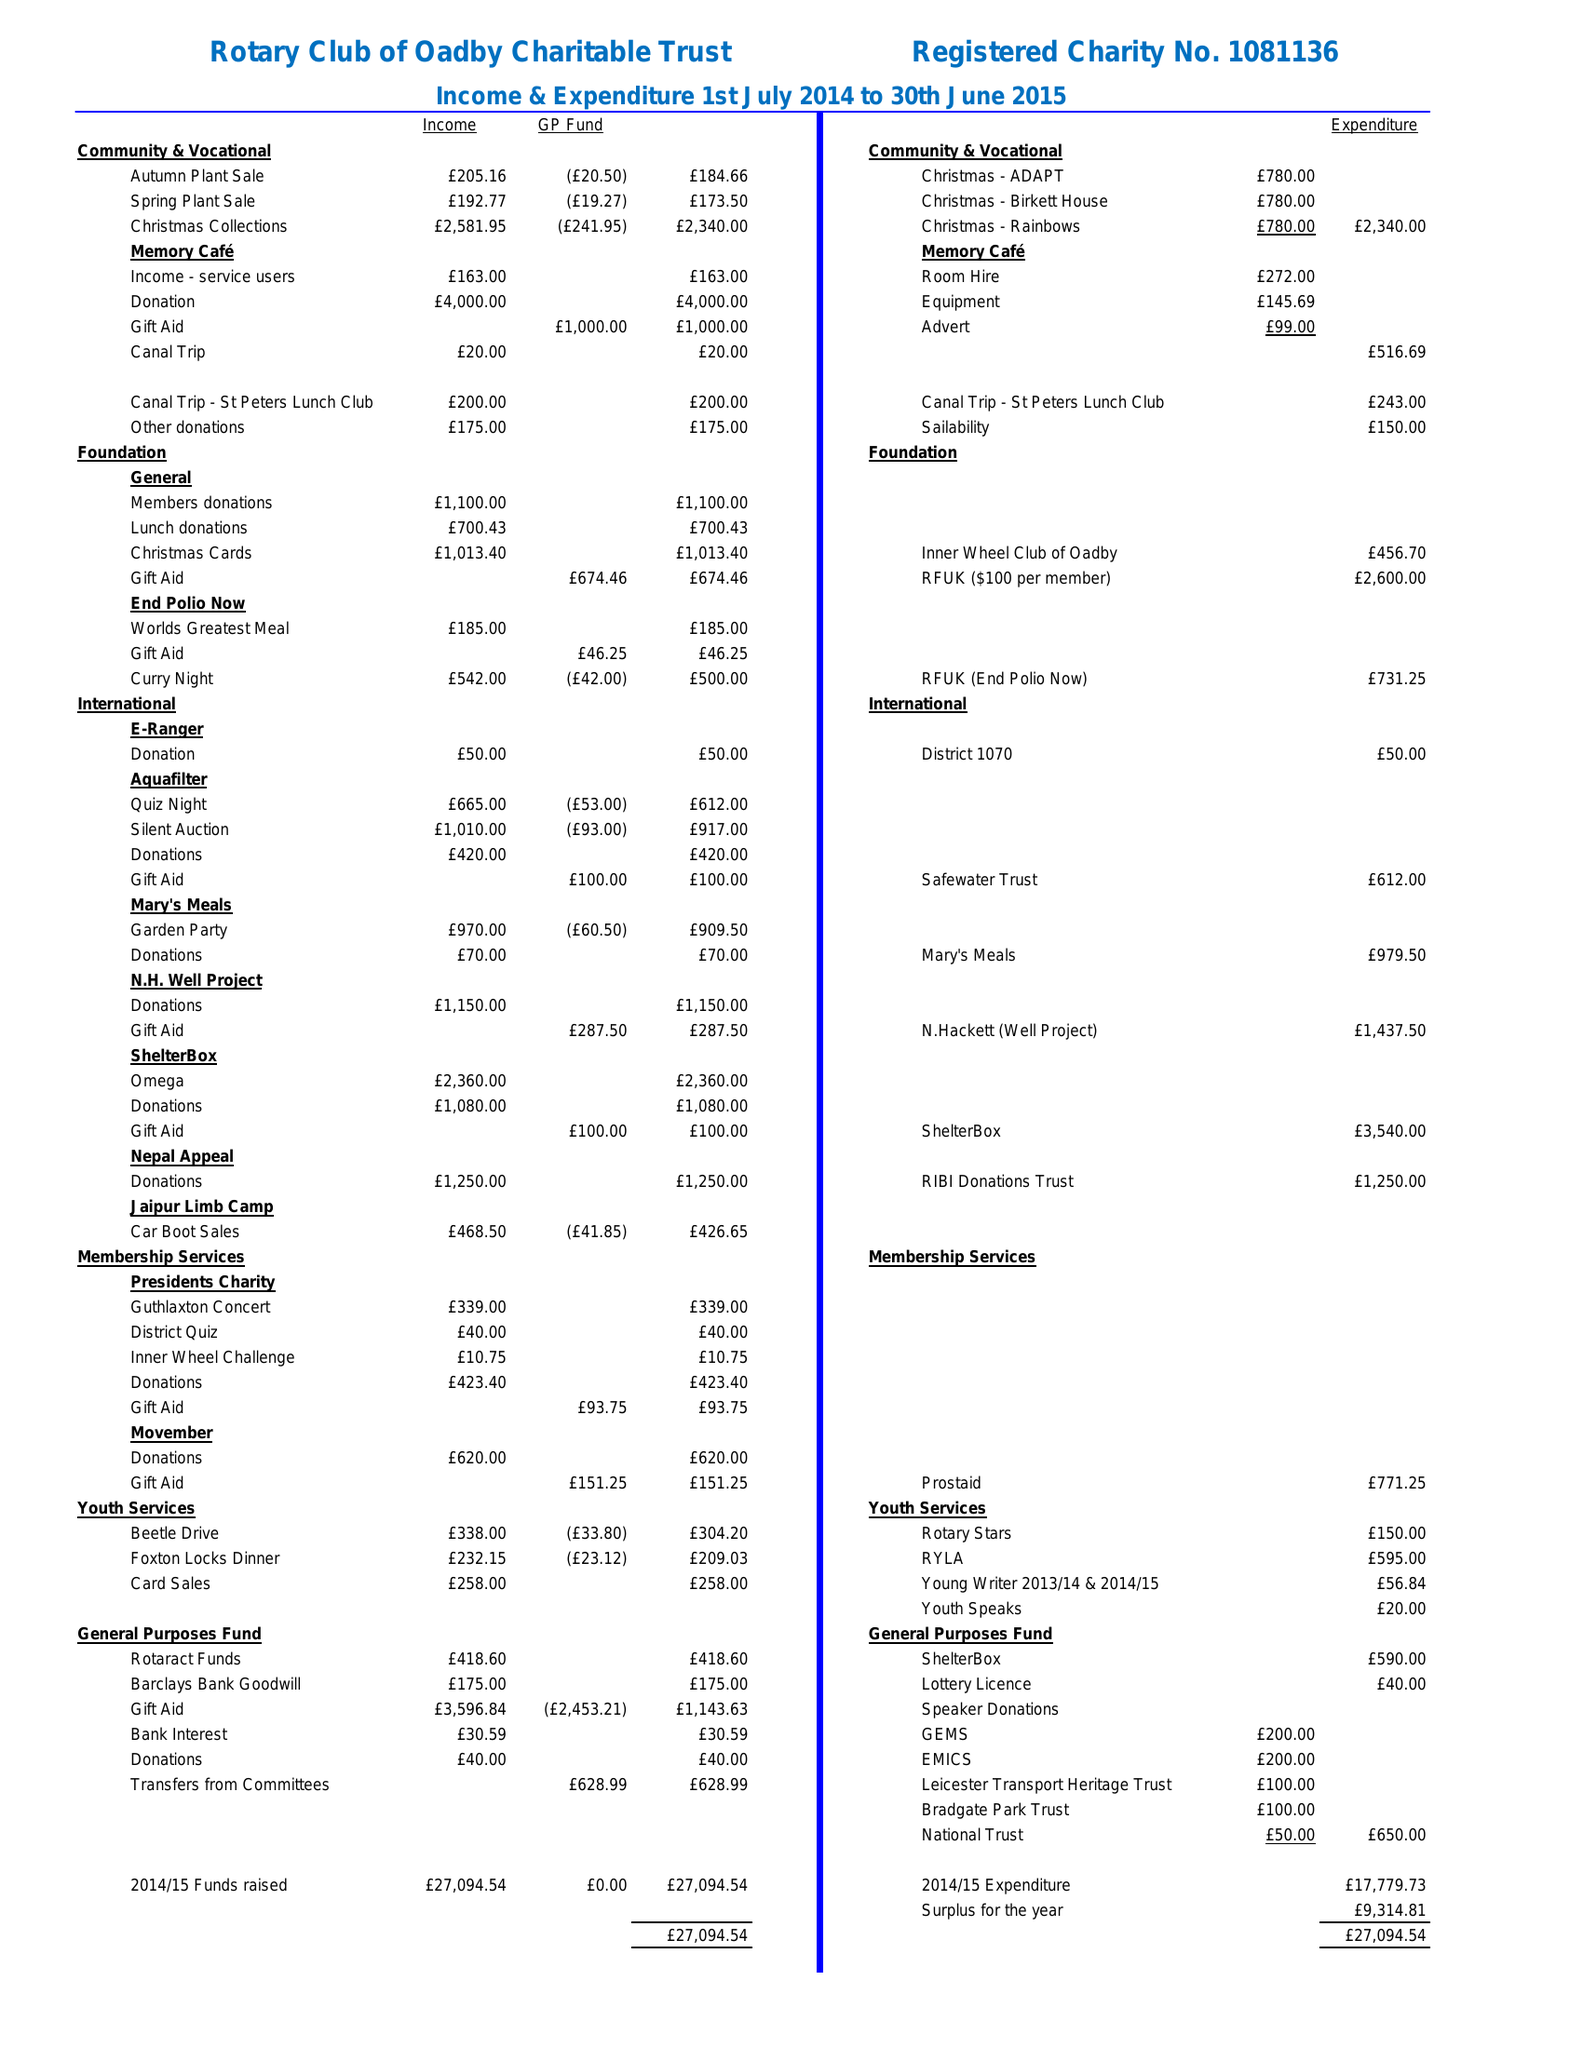What is the value for the charity_number?
Answer the question using a single word or phrase. 1081136 